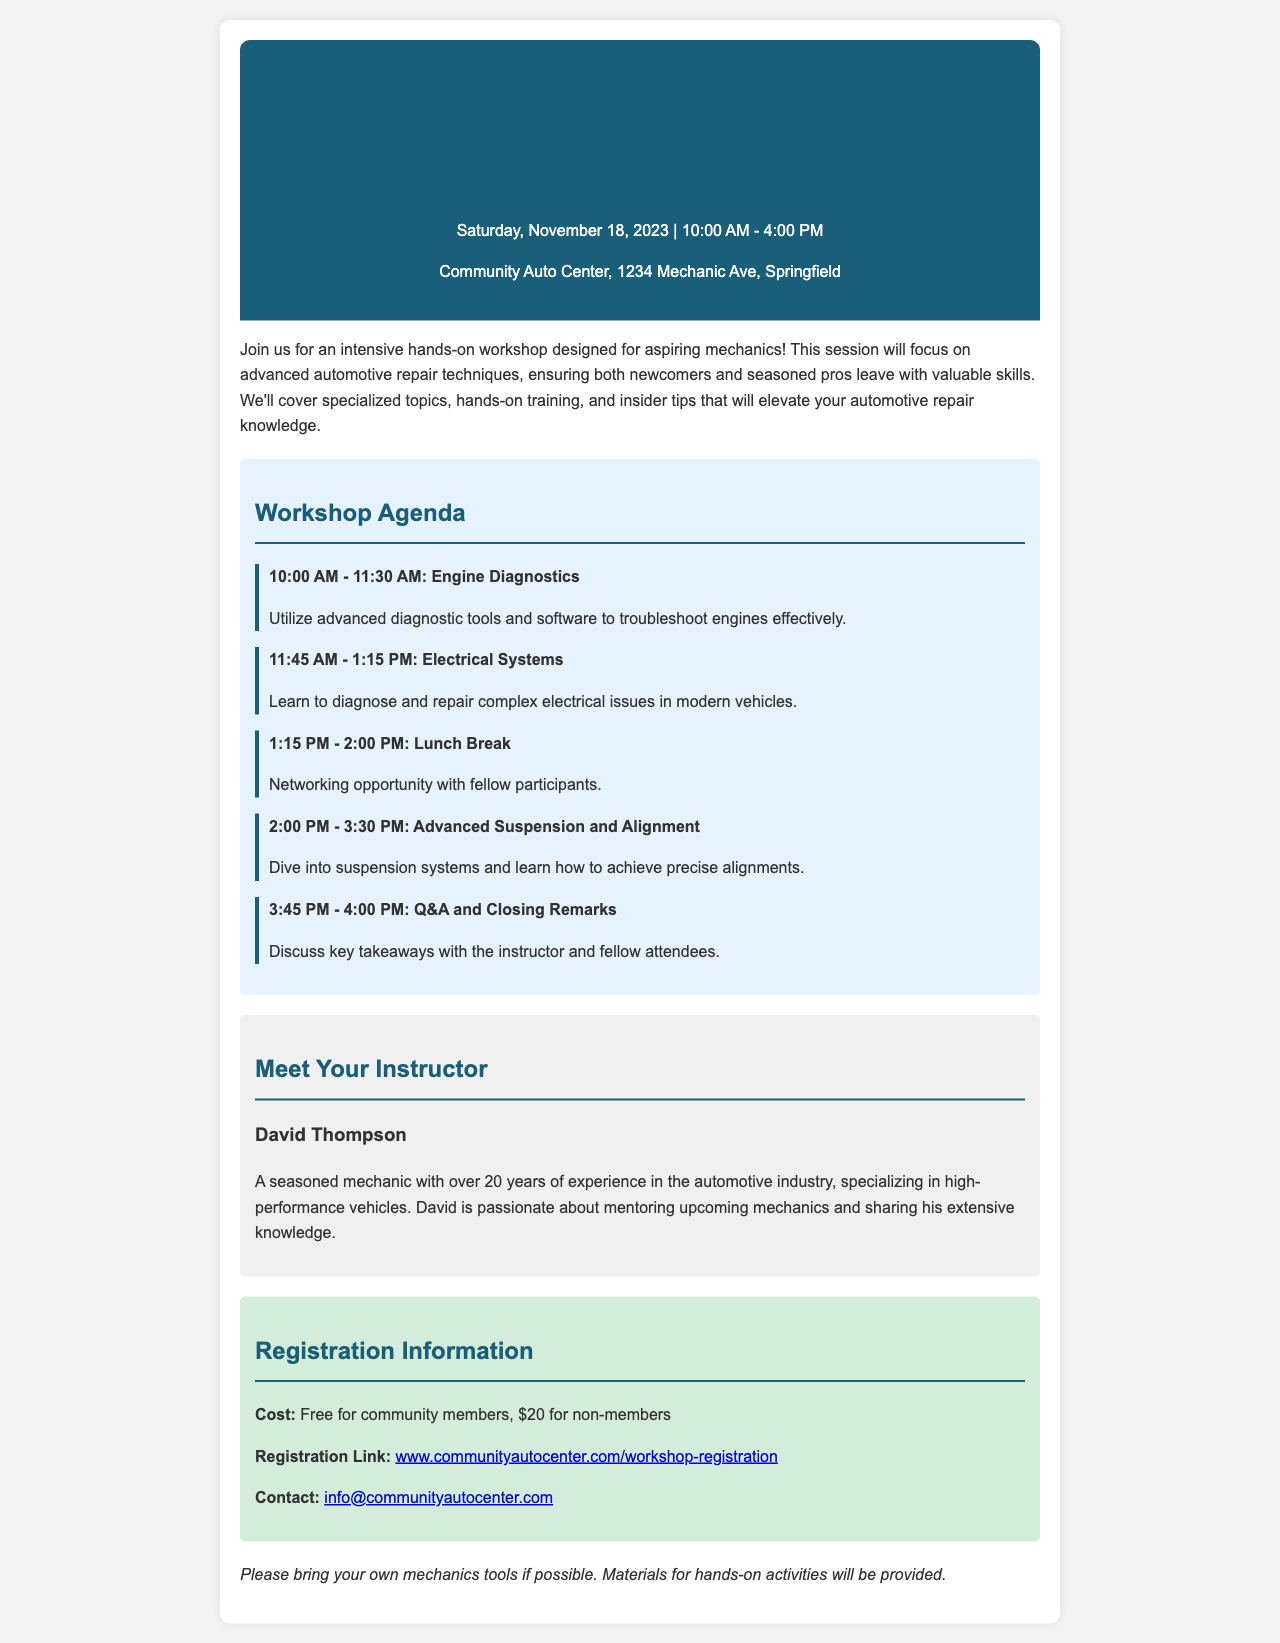What is the date of the workshop? The date of the workshop is explicitly mentioned in the document as Saturday, November 18, 2023.
Answer: November 18, 2023 Who is the instructor for the workshop? The document provides the name of the instructor as David Thompson in the section about meeting the instructor.
Answer: David Thompson What is the cost for non-members? The cost for non-members is stated in the registration information as $20.
Answer: $20 What time does the lunch break start? The agenda clearly states that the lunch break starts at 1:15 PM.
Answer: 1:15 PM What is one of the topics covered in the workshop? The agenda lists numerous topics such as Engine Diagnostics, which is a specific key topic being covered.
Answer: Engine Diagnostics How long is the workshop scheduled to last? The total duration of the workshop is indicated by the start and end time, from 10:00 AM to 4:00 PM, which is 6 hours.
Answer: 6 hours What type of activities will participants be participating in? The document mentions that the workshop will involve intensive hands-on training, which defines the nature of the activities planned for participants.
Answer: Hands-on training What should participants bring if possible? The additional information section specifies that participants should ideally bring their own mechanics tools.
Answer: Mechanics tools 